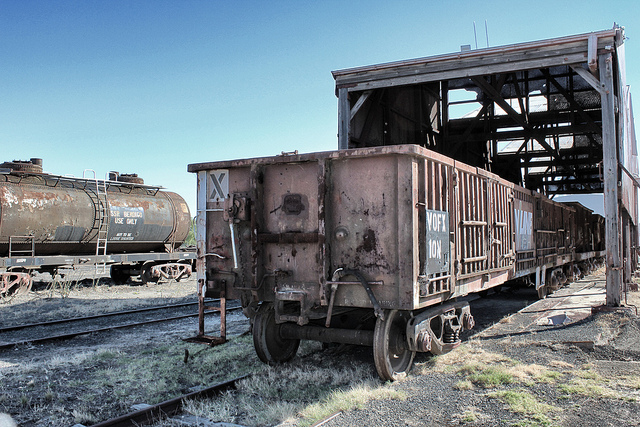Read and extract the text from this image. X USE 